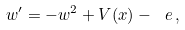<formula> <loc_0><loc_0><loc_500><loc_500>w ^ { \prime } = - w ^ { 2 } + V ( x ) - \ e \, ,</formula> 